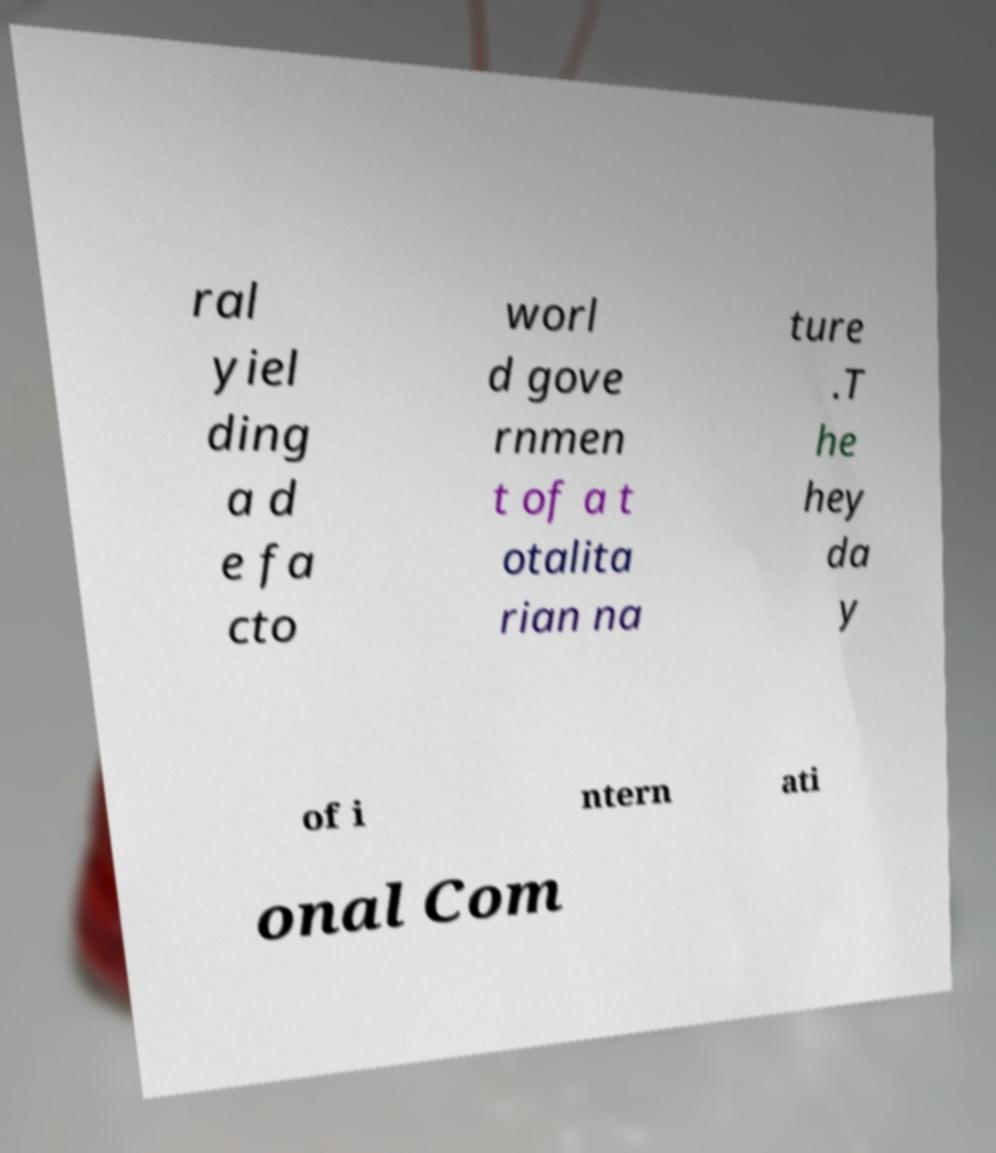Can you read and provide the text displayed in the image?This photo seems to have some interesting text. Can you extract and type it out for me? ral yiel ding a d e fa cto worl d gove rnmen t of a t otalita rian na ture .T he hey da y of i ntern ati onal Com 